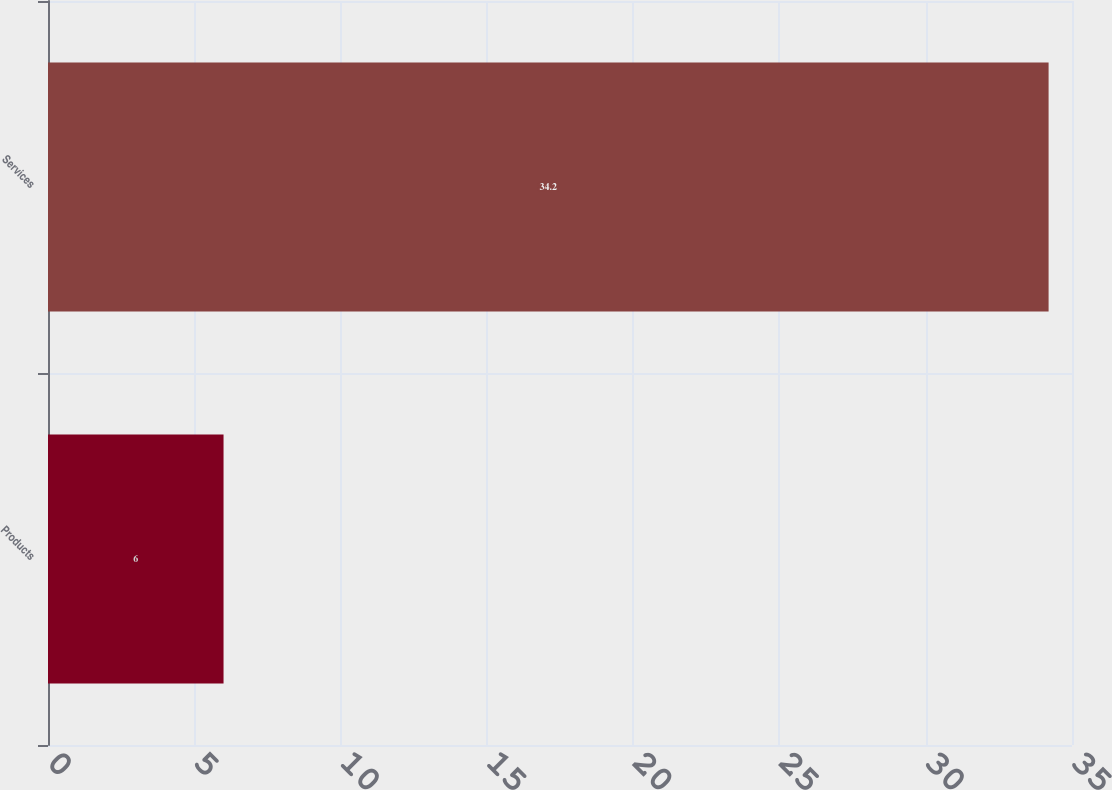Convert chart to OTSL. <chart><loc_0><loc_0><loc_500><loc_500><bar_chart><fcel>Products<fcel>Services<nl><fcel>6<fcel>34.2<nl></chart> 